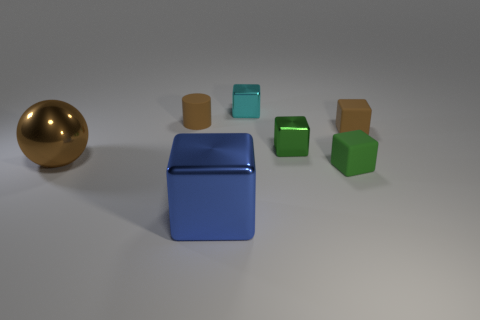Subtract all green cylinders. How many green cubes are left? 2 Add 1 cyan things. How many objects exist? 8 Subtract all small cyan metallic cubes. How many cubes are left? 4 Subtract 3 cubes. How many cubes are left? 2 Subtract all green cubes. How many cubes are left? 3 Subtract all cylinders. How many objects are left? 6 Subtract all tiny cyan things. Subtract all tiny green rubber things. How many objects are left? 5 Add 1 cyan metallic things. How many cyan metallic things are left? 2 Add 1 small matte blocks. How many small matte blocks exist? 3 Subtract 1 blue cubes. How many objects are left? 6 